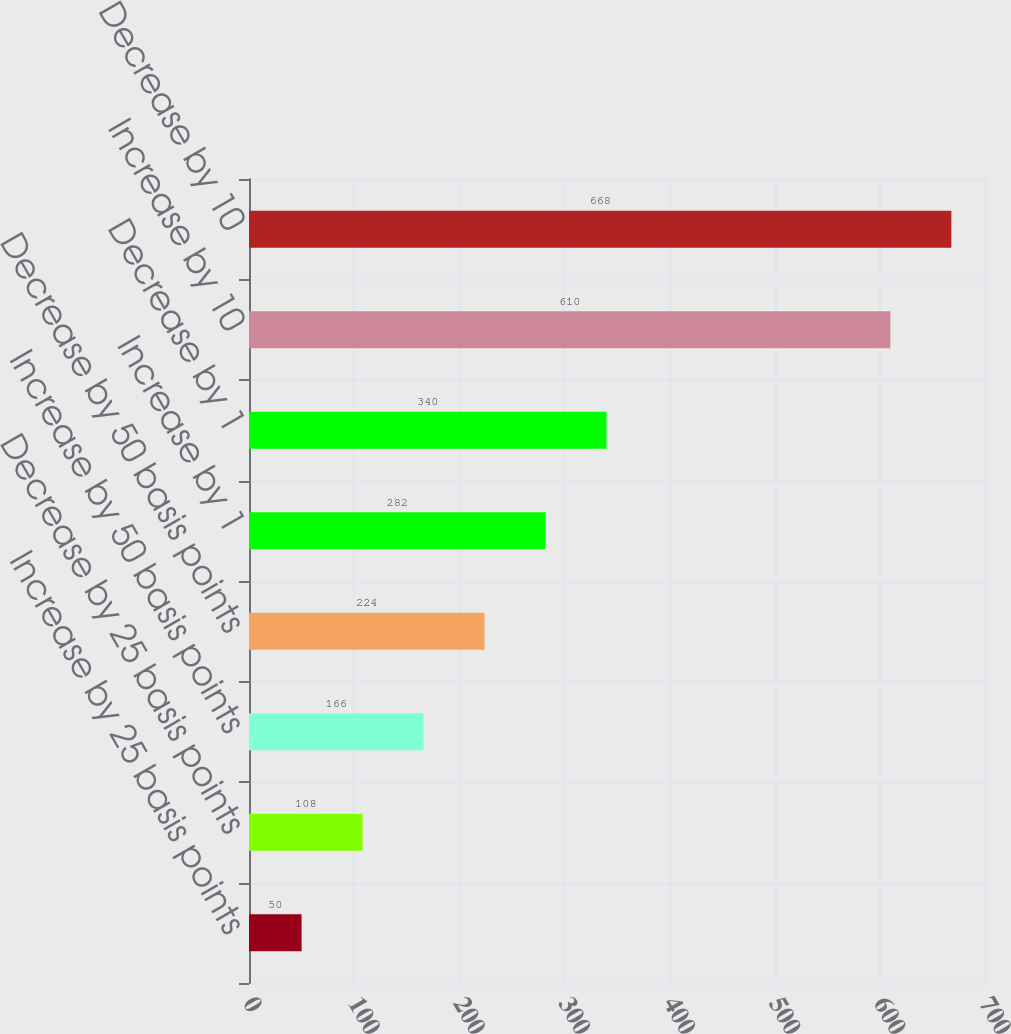<chart> <loc_0><loc_0><loc_500><loc_500><bar_chart><fcel>Increase by 25 basis points<fcel>Decrease by 25 basis points<fcel>Increase by 50 basis points<fcel>Decrease by 50 basis points<fcel>Increase by 1<fcel>Decrease by 1<fcel>Increase by 10<fcel>Decrease by 10<nl><fcel>50<fcel>108<fcel>166<fcel>224<fcel>282<fcel>340<fcel>610<fcel>668<nl></chart> 